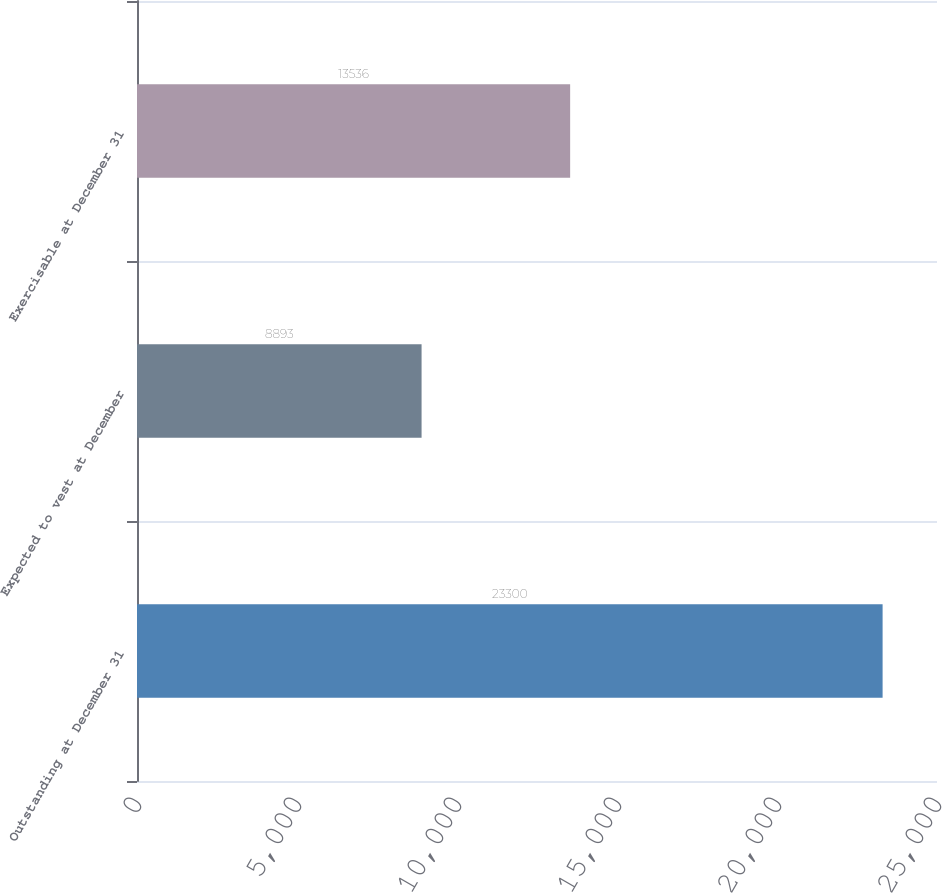Convert chart. <chart><loc_0><loc_0><loc_500><loc_500><bar_chart><fcel>Outstanding at December 31<fcel>Expected to vest at December<fcel>Exercisable at December 31<nl><fcel>23300<fcel>8893<fcel>13536<nl></chart> 